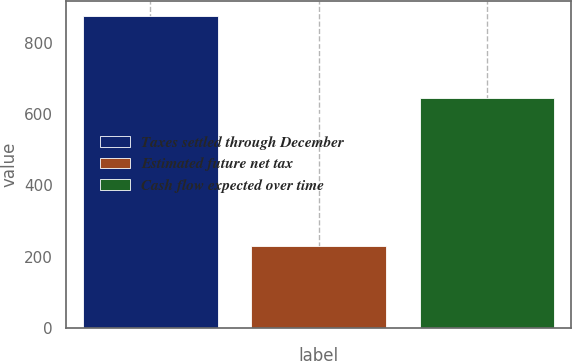<chart> <loc_0><loc_0><loc_500><loc_500><bar_chart><fcel>Taxes settled through December<fcel>Estimated future net tax<fcel>Cash flow expected over time<nl><fcel>875<fcel>229<fcel>646<nl></chart> 